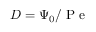<formula> <loc_0><loc_0><loc_500><loc_500>D = \Psi _ { 0 } / P e</formula> 